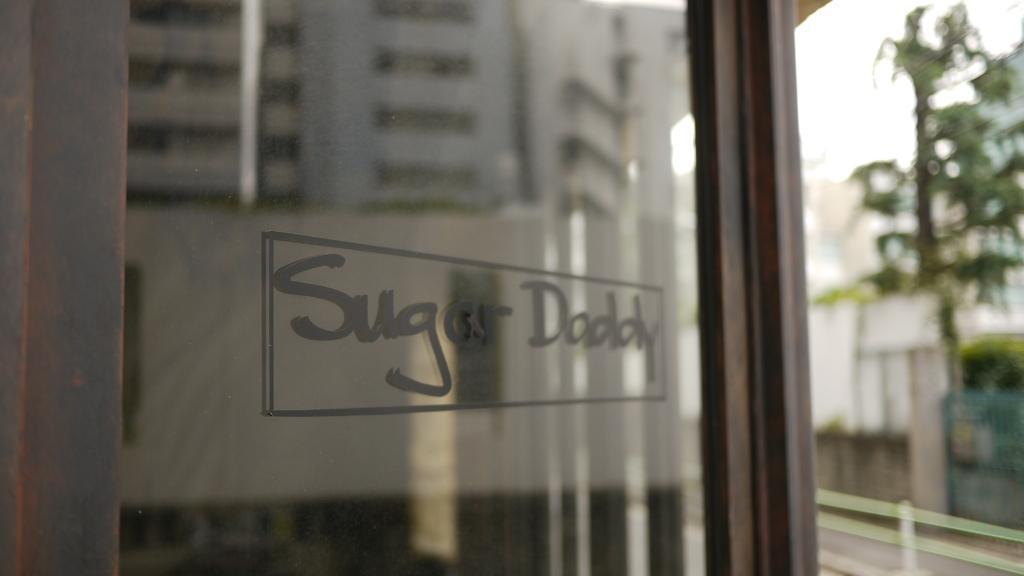Please provide a concise description of this image. This is a blurred image. Here we can see glass and on it there is a text. Here we can see tree and white sky. 